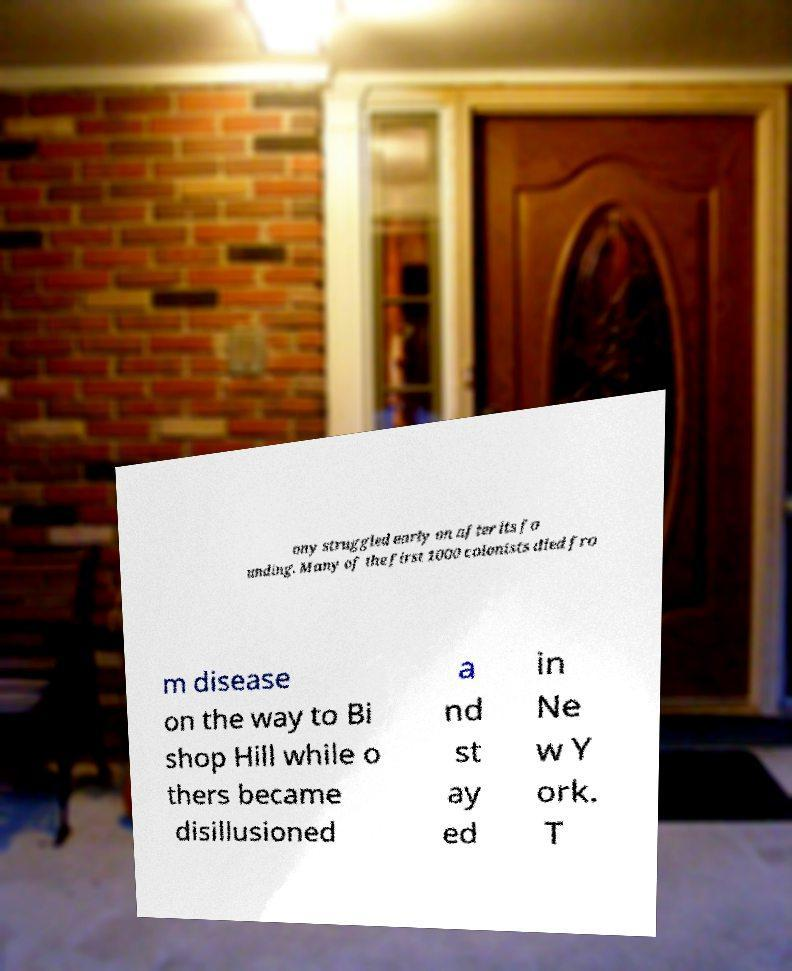Could you assist in decoding the text presented in this image and type it out clearly? ony struggled early on after its fo unding. Many of the first 1000 colonists died fro m disease on the way to Bi shop Hill while o thers became disillusioned a nd st ay ed in Ne w Y ork. T 